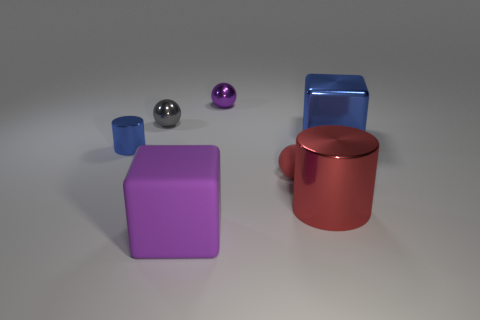How big is the blue object behind the cylinder that is behind the red rubber thing?
Make the answer very short. Large. Is the purple object that is behind the big purple block made of the same material as the big object that is in front of the red metallic thing?
Provide a succinct answer. No. Is there another small red object of the same shape as the red metal thing?
Your answer should be compact. No. How many objects are either blue metal things that are to the left of the red metal object or spheres?
Your response must be concise. 4. Is the number of shiny cylinders in front of the tiny red matte thing greater than the number of big blue metallic objects to the left of the purple rubber object?
Your answer should be compact. Yes. What number of rubber objects are blue cubes or gray objects?
Offer a terse response. 0. What is the material of the tiny thing that is the same color as the large matte object?
Provide a succinct answer. Metal. Are there fewer metallic spheres that are behind the small red rubber ball than things in front of the big shiny block?
Your answer should be compact. Yes. What number of things are tiny blue matte cubes or small red rubber things that are right of the purple matte block?
Provide a short and direct response. 1. What is the material of the red thing that is the same size as the purple shiny sphere?
Ensure brevity in your answer.  Rubber. 